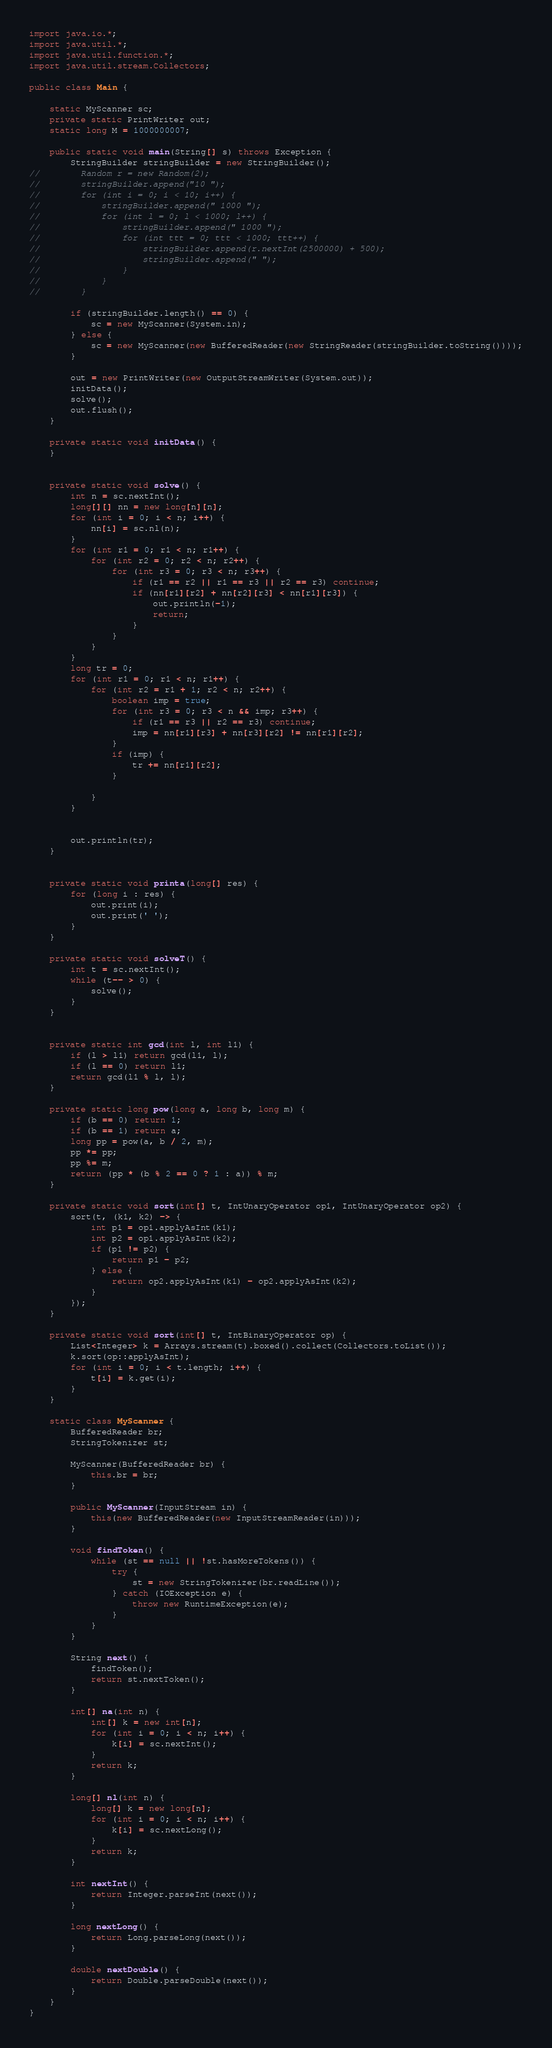<code> <loc_0><loc_0><loc_500><loc_500><_Java_>
import java.io.*;
import java.util.*;
import java.util.function.*;
import java.util.stream.Collectors;

public class Main {

    static MyScanner sc;
    private static PrintWriter out;
    static long M = 1000000007;

    public static void main(String[] s) throws Exception {
        StringBuilder stringBuilder = new StringBuilder();
//        Random r = new Random(2);
//        stringBuilder.append("10 ");
//        for (int i = 0; i < 10; i++) {
//            stringBuilder.append(" 1000 ");
//            for (int l = 0; l < 1000; l++) {
//                stringBuilder.append(" 1000 ");
//                for (int ttt = 0; ttt < 1000; ttt++) {
//                    stringBuilder.append(r.nextInt(2500000) + 500);
//                    stringBuilder.append(" ");
//                }
//            }
//        }

        if (stringBuilder.length() == 0) {
            sc = new MyScanner(System.in);
        } else {
            sc = new MyScanner(new BufferedReader(new StringReader(stringBuilder.toString())));
        }

        out = new PrintWriter(new OutputStreamWriter(System.out));
        initData();
        solve();
        out.flush();
    }

    private static void initData() {
    }


    private static void solve() {
        int n = sc.nextInt();
        long[][] nn = new long[n][n];
        for (int i = 0; i < n; i++) {
            nn[i] = sc.nl(n);
        }
        for (int r1 = 0; r1 < n; r1++) {
            for (int r2 = 0; r2 < n; r2++) {
                for (int r3 = 0; r3 < n; r3++) {
                    if (r1 == r2 || r1 == r3 || r2 == r3) continue;
                    if (nn[r1][r2] + nn[r2][r3] < nn[r1][r3]) {
                        out.println(-1);
                        return;
                    }
                }
            }
        }
        long tr = 0;
        for (int r1 = 0; r1 < n; r1++) {
            for (int r2 = r1 + 1; r2 < n; r2++) {
                boolean imp = true;
                for (int r3 = 0; r3 < n && imp; r3++) {
                    if (r1 == r3 || r2 == r3) continue;
                    imp = nn[r1][r3] + nn[r3][r2] != nn[r1][r2];
                }
                if (imp) {
                    tr += nn[r1][r2];
                }

            }
        }


        out.println(tr);
    }


    private static void printa(long[] res) {
        for (long i : res) {
            out.print(i);
            out.print(' ');
        }
    }

    private static void solveT() {
        int t = sc.nextInt();
        while (t-- > 0) {
            solve();
        }
    }


    private static int gcd(int l, int l1) {
        if (l > l1) return gcd(l1, l);
        if (l == 0) return l1;
        return gcd(l1 % l, l);
    }

    private static long pow(long a, long b, long m) {
        if (b == 0) return 1;
        if (b == 1) return a;
        long pp = pow(a, b / 2, m);
        pp *= pp;
        pp %= m;
        return (pp * (b % 2 == 0 ? 1 : a)) % m;
    }

    private static void sort(int[] t, IntUnaryOperator op1, IntUnaryOperator op2) {
        sort(t, (k1, k2) -> {
            int p1 = op1.applyAsInt(k1);
            int p2 = op1.applyAsInt(k2);
            if (p1 != p2) {
                return p1 - p2;
            } else {
                return op2.applyAsInt(k1) - op2.applyAsInt(k2);
            }
        });
    }

    private static void sort(int[] t, IntBinaryOperator op) {
        List<Integer> k = Arrays.stream(t).boxed().collect(Collectors.toList());
        k.sort(op::applyAsInt);
        for (int i = 0; i < t.length; i++) {
            t[i] = k.get(i);
        }
    }

    static class MyScanner {
        BufferedReader br;
        StringTokenizer st;

        MyScanner(BufferedReader br) {
            this.br = br;
        }

        public MyScanner(InputStream in) {
            this(new BufferedReader(new InputStreamReader(in)));
        }

        void findToken() {
            while (st == null || !st.hasMoreTokens()) {
                try {
                    st = new StringTokenizer(br.readLine());
                } catch (IOException e) {
                    throw new RuntimeException(e);
                }
            }
        }

        String next() {
            findToken();
            return st.nextToken();
        }

        int[] na(int n) {
            int[] k = new int[n];
            for (int i = 0; i < n; i++) {
                k[i] = sc.nextInt();
            }
            return k;
        }

        long[] nl(int n) {
            long[] k = new long[n];
            for (int i = 0; i < n; i++) {
                k[i] = sc.nextLong();
            }
            return k;
        }

        int nextInt() {
            return Integer.parseInt(next());
        }

        long nextLong() {
            return Long.parseLong(next());
        }

        double nextDouble() {
            return Double.parseDouble(next());
        }
    }
}</code> 